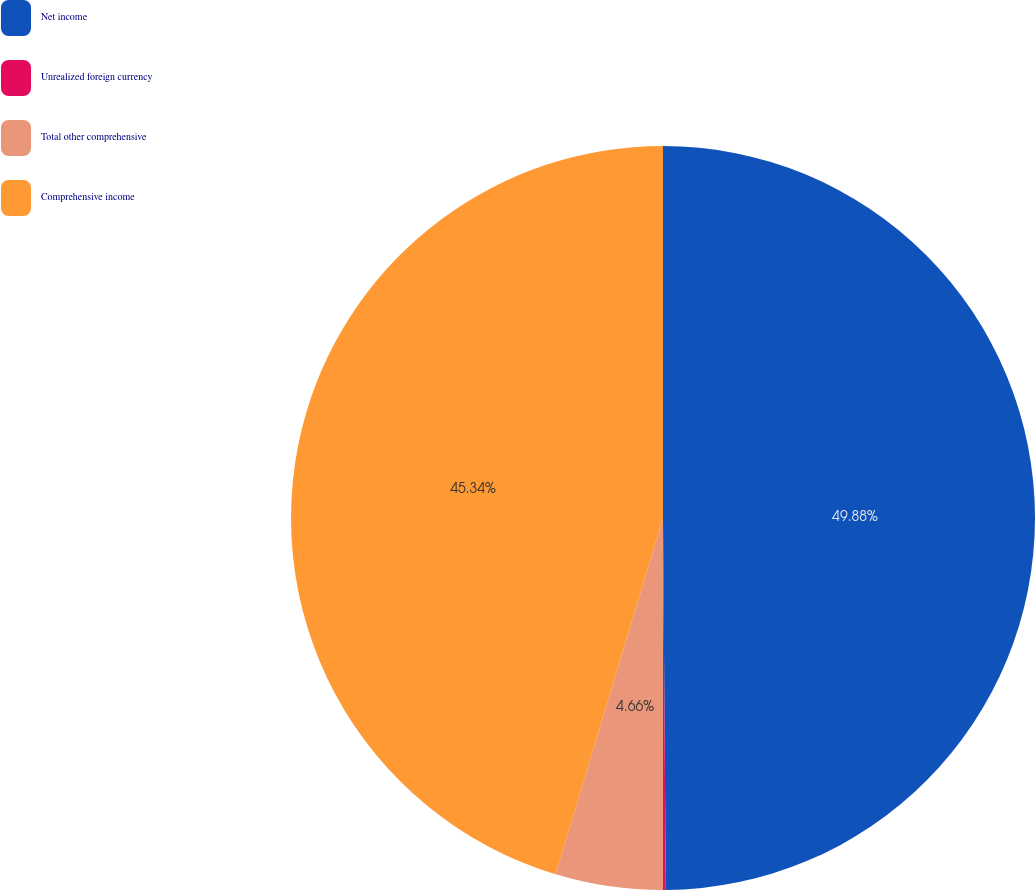Convert chart to OTSL. <chart><loc_0><loc_0><loc_500><loc_500><pie_chart><fcel>Net income<fcel>Unrealized foreign currency<fcel>Total other comprehensive<fcel>Comprehensive income<nl><fcel>49.88%<fcel>0.12%<fcel>4.66%<fcel>45.34%<nl></chart> 